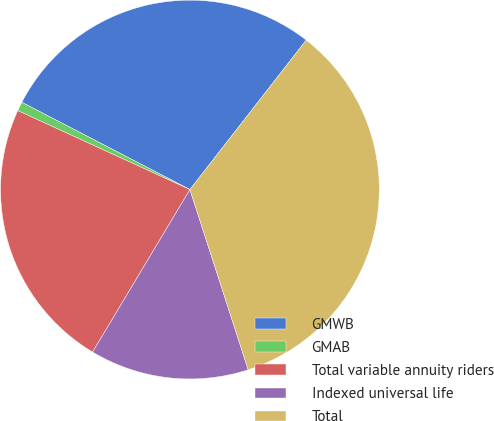Convert chart. <chart><loc_0><loc_0><loc_500><loc_500><pie_chart><fcel>GMWB<fcel>GMAB<fcel>Total variable annuity riders<fcel>Indexed universal life<fcel>Total<nl><fcel>27.91%<fcel>0.78%<fcel>23.26%<fcel>13.57%<fcel>34.5%<nl></chart> 